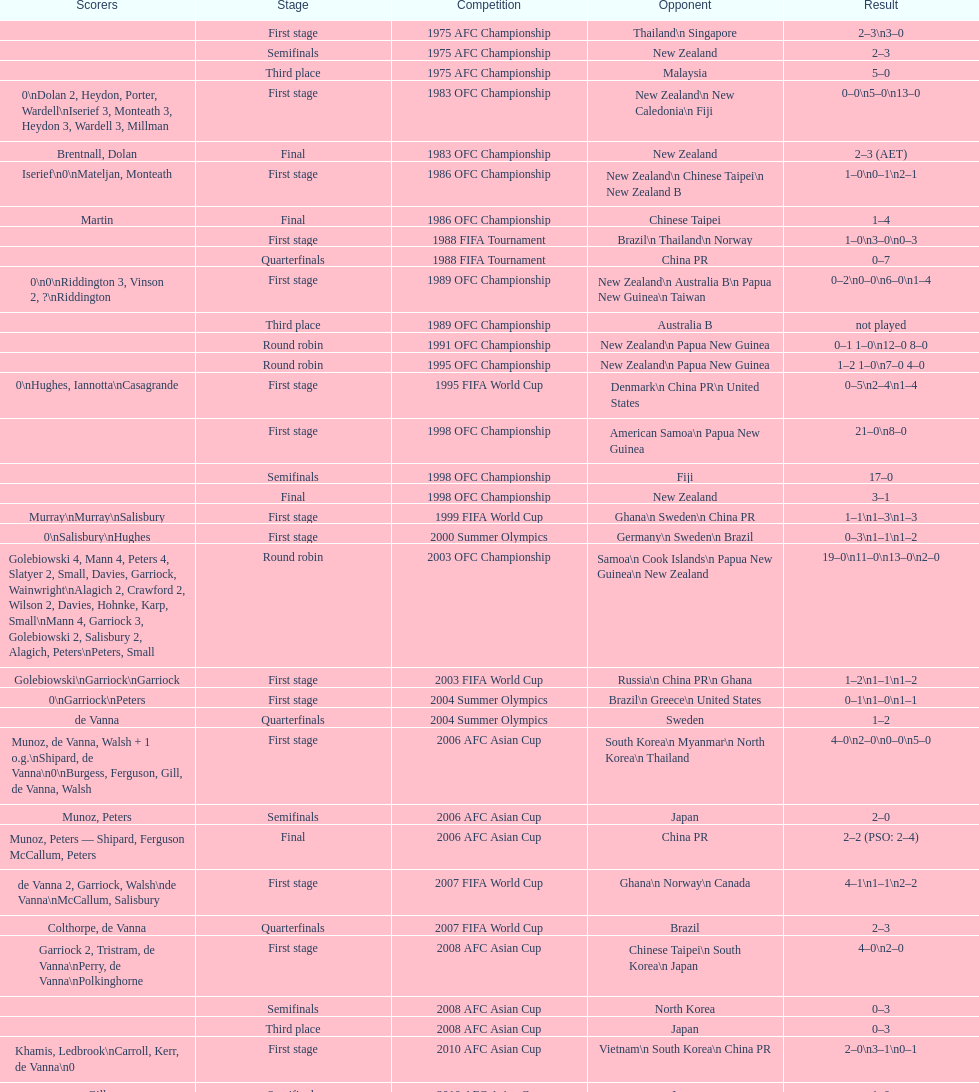Who was this team's next opponent after facing new zealand in the first stage of the 1986 ofc championship? Chinese Taipei. 